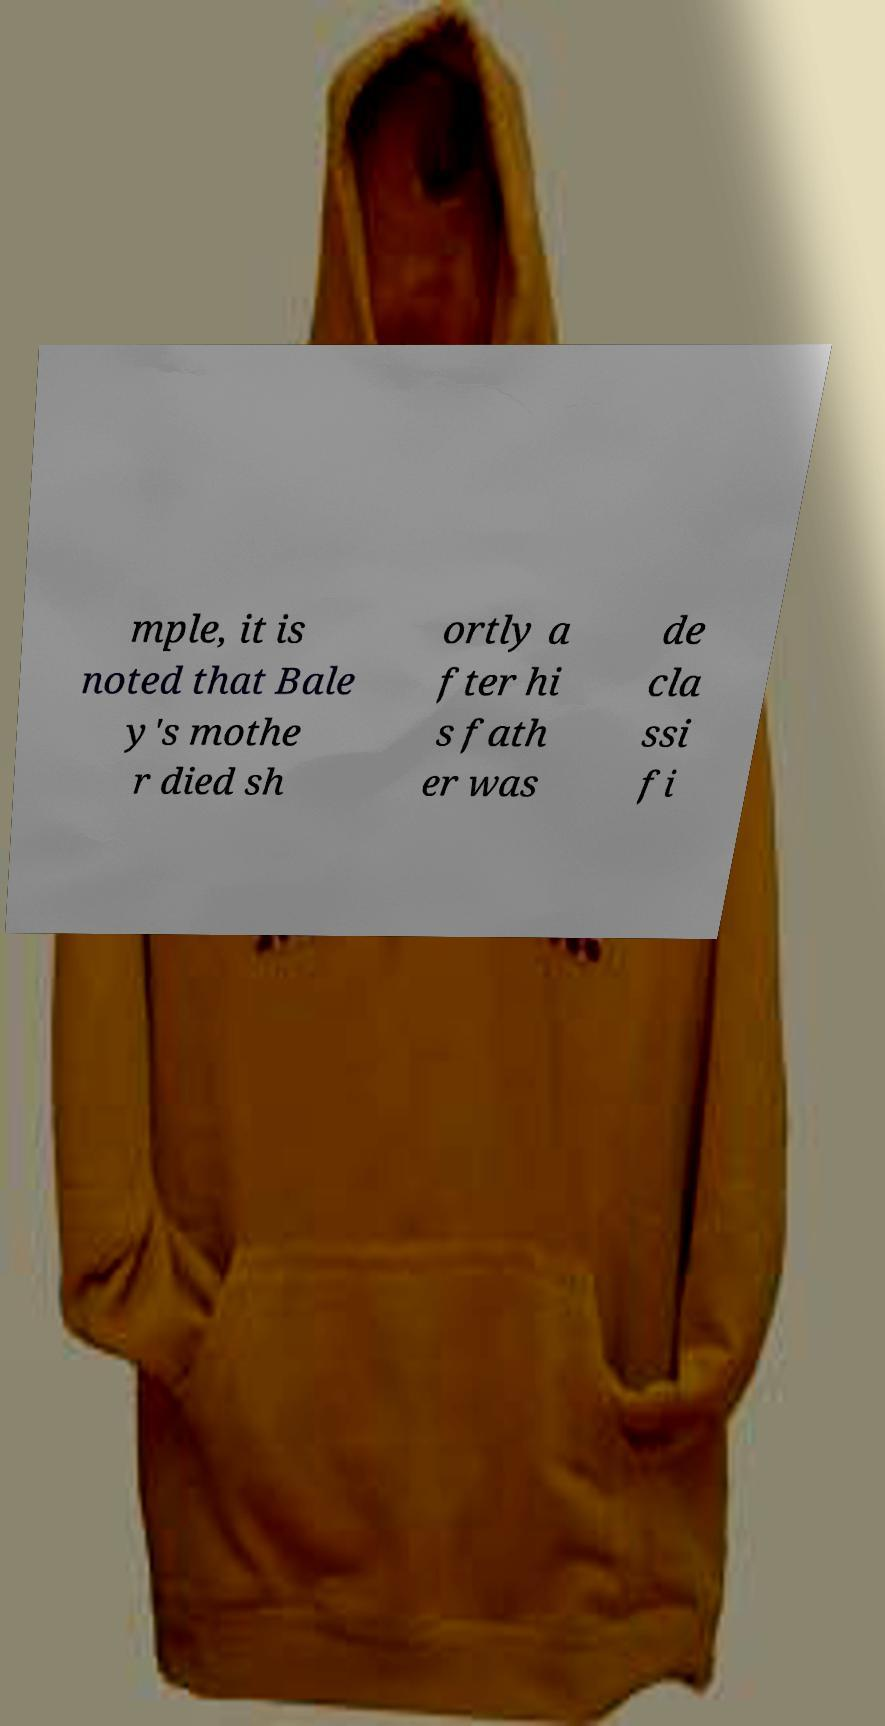Please identify and transcribe the text found in this image. mple, it is noted that Bale y's mothe r died sh ortly a fter hi s fath er was de cla ssi fi 